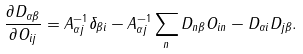Convert formula to latex. <formula><loc_0><loc_0><loc_500><loc_500>\frac { \partial D _ { \alpha \beta } } { \partial O _ { i j } } = A _ { \alpha j } ^ { - 1 } \delta _ { \beta i } - A _ { \alpha j } ^ { - 1 } \sum _ { n } D _ { n \beta } O _ { i n } - D _ { \alpha i } D _ { j \beta } .</formula> 